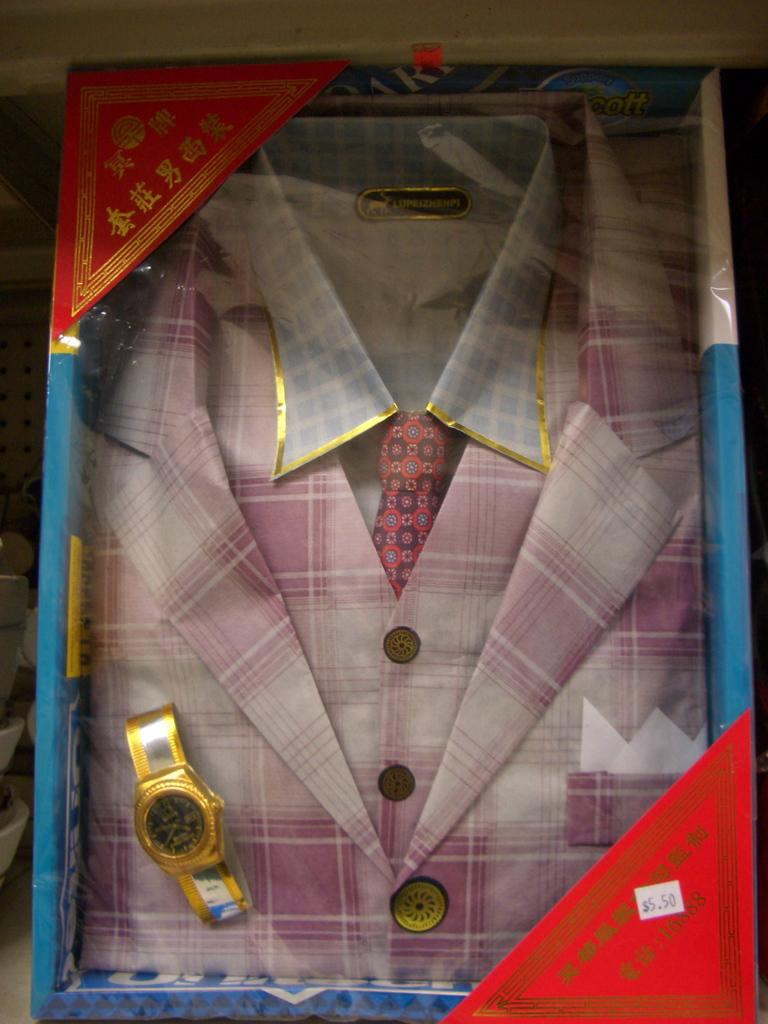<image>
Write a terse but informative summary of the picture. A packaged mens suit with a watch included with a price tag of five dollars and fifty cents. 